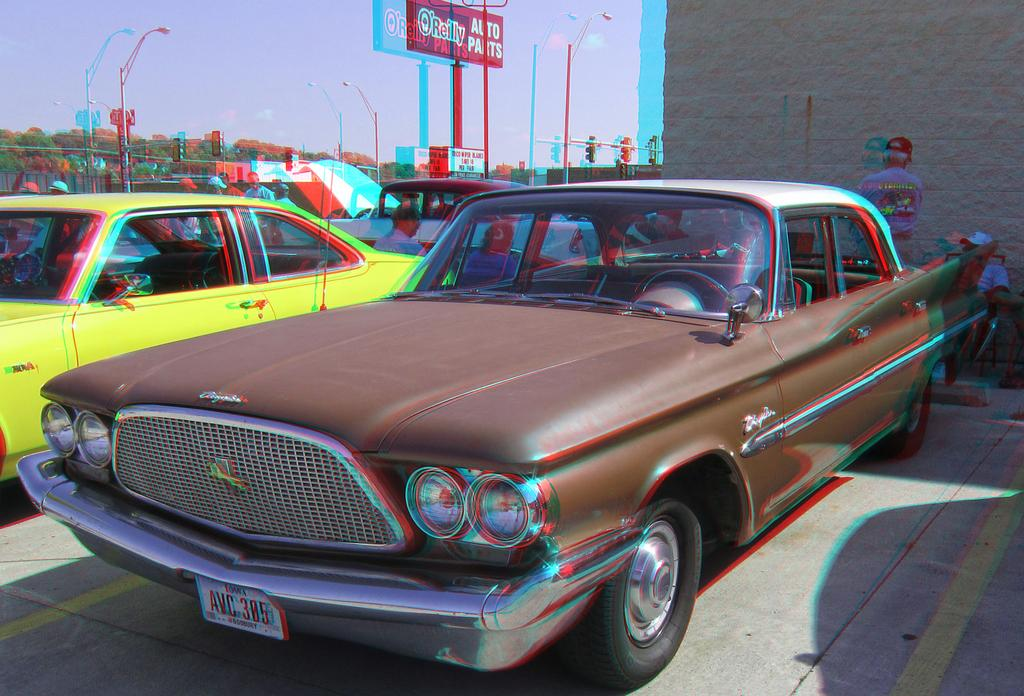What is parked on the road in the image? There is a car parked on the road in the image. What can be seen in the background of the image? There are vehicles, people, a wall, the sky, trees, poles, and banners in the background. Can you describe the actions of the people in the background? Some people are sitting, while others are standing. What type of treatment is being administered to the jeans in the image? There are no jeans present in the image, and therefore no treatment is being administered. What is the person in the image writing on? There is no person writing in the image. 